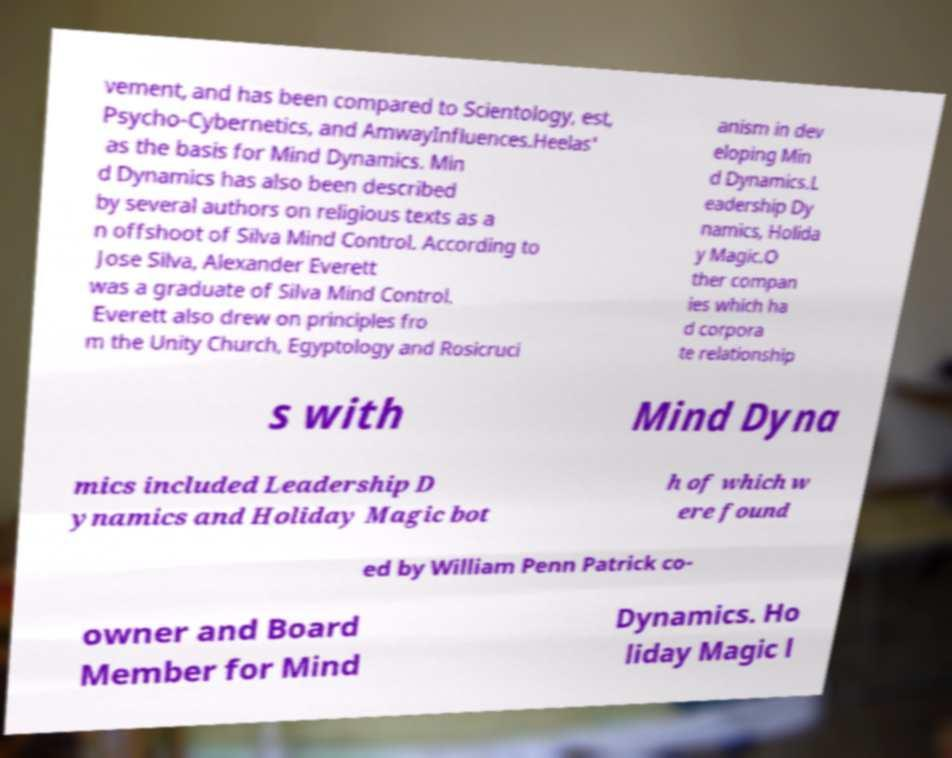For documentation purposes, I need the text within this image transcribed. Could you provide that? vement, and has been compared to Scientology, est, Psycho-Cybernetics, and AmwayInfluences.Heelas' as the basis for Mind Dynamics. Min d Dynamics has also been described by several authors on religious texts as a n offshoot of Silva Mind Control. According to Jose Silva, Alexander Everett was a graduate of Silva Mind Control. Everett also drew on principles fro m the Unity Church, Egyptology and Rosicruci anism in dev eloping Min d Dynamics.L eadership Dy namics, Holida y Magic.O ther compan ies which ha d corpora te relationship s with Mind Dyna mics included Leadership D ynamics and Holiday Magic bot h of which w ere found ed by William Penn Patrick co- owner and Board Member for Mind Dynamics. Ho liday Magic l 